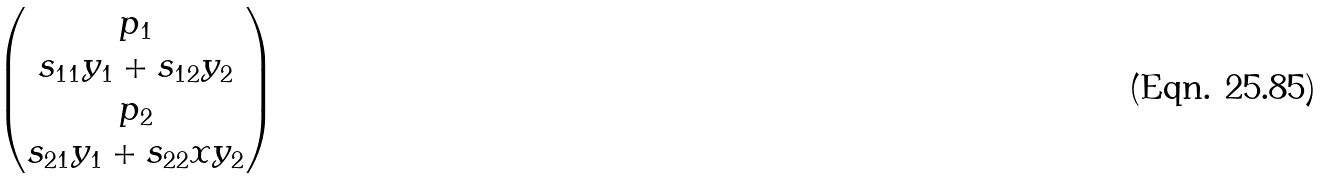Convert formula to latex. <formula><loc_0><loc_0><loc_500><loc_500>\begin{pmatrix} p _ { 1 } \\ s _ { 1 1 } y _ { 1 } + s _ { 1 2 } y _ { 2 } \\ p _ { 2 } \\ s _ { 2 1 } y _ { 1 } + s _ { 2 2 } x y _ { 2 } \end{pmatrix}</formula> 